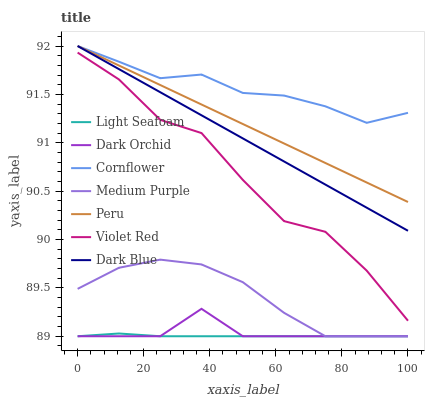Does Violet Red have the minimum area under the curve?
Answer yes or no. No. Does Violet Red have the maximum area under the curve?
Answer yes or no. No. Is Dark Orchid the smoothest?
Answer yes or no. No. Is Dark Orchid the roughest?
Answer yes or no. No. Does Violet Red have the lowest value?
Answer yes or no. No. Does Violet Red have the highest value?
Answer yes or no. No. Is Light Seafoam less than Peru?
Answer yes or no. Yes. Is Peru greater than Light Seafoam?
Answer yes or no. Yes. Does Light Seafoam intersect Peru?
Answer yes or no. No. 